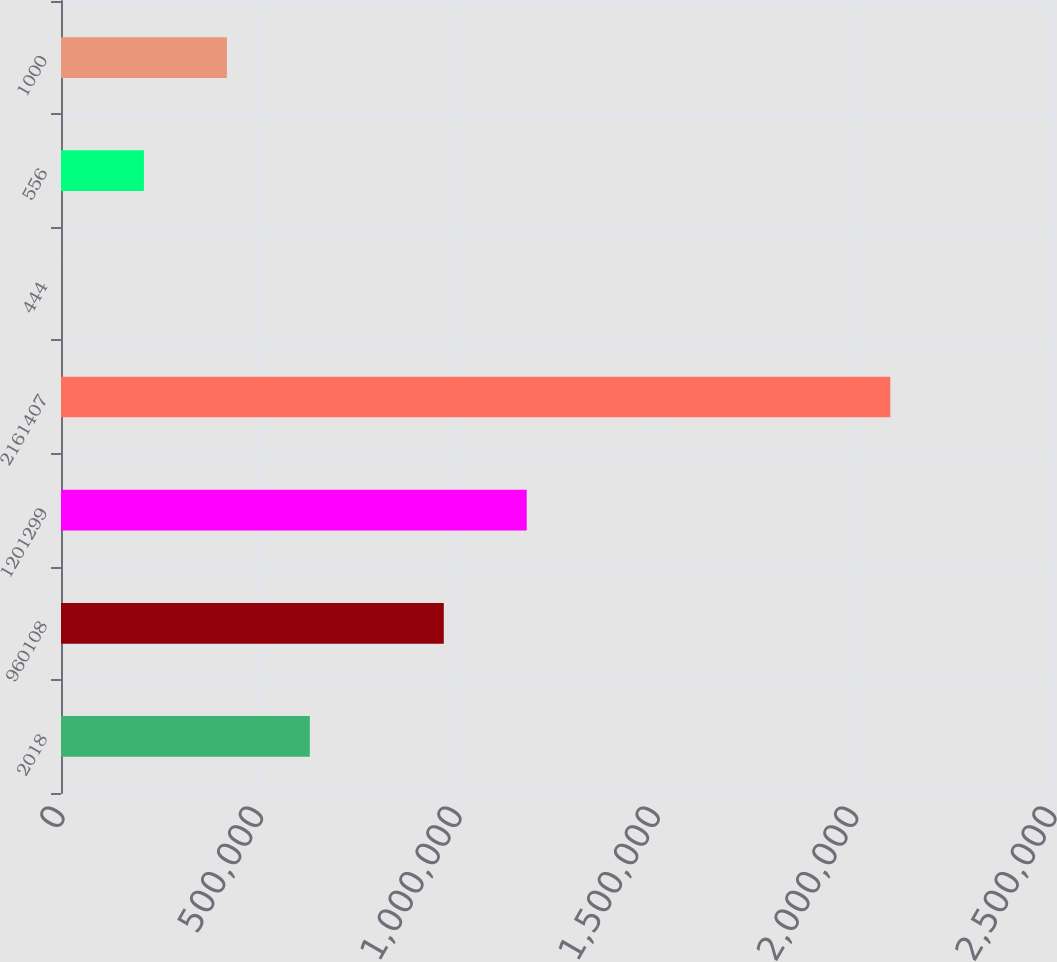<chart> <loc_0><loc_0><loc_500><loc_500><bar_chart><fcel>2018<fcel>960108<fcel>1201299<fcel>2161407<fcel>444<fcel>556<fcel>1000<nl><fcel>627045<fcel>964662<fcel>1.17366e+06<fcel>2.09004e+06<fcel>46.2<fcel>209046<fcel>418045<nl></chart> 